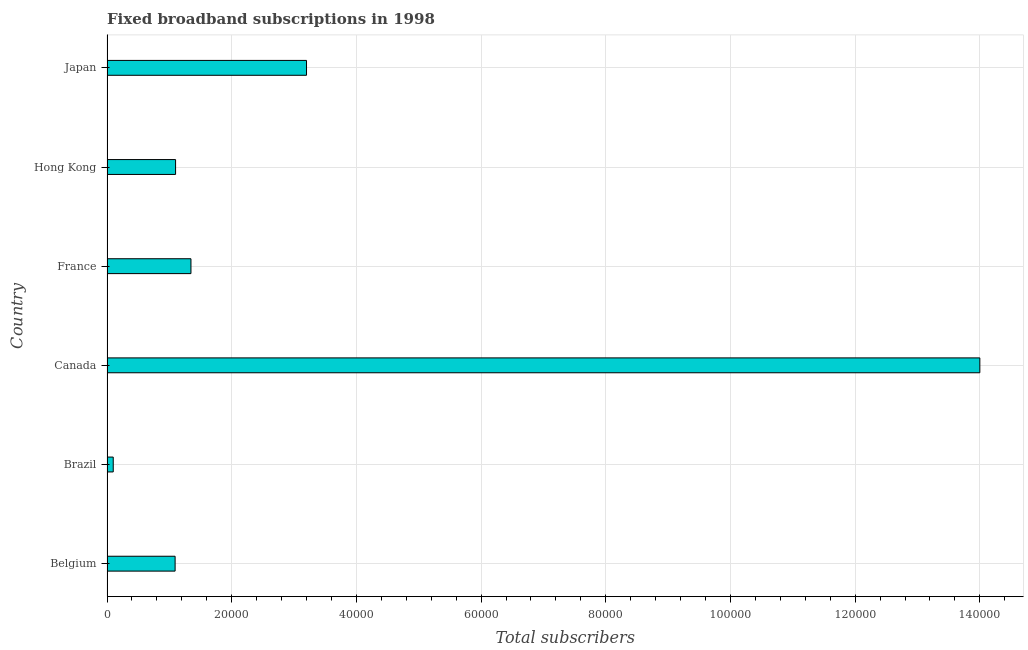Does the graph contain any zero values?
Ensure brevity in your answer.  No. What is the title of the graph?
Offer a very short reply. Fixed broadband subscriptions in 1998. What is the label or title of the X-axis?
Keep it short and to the point. Total subscribers. What is the total number of fixed broadband subscriptions in Hong Kong?
Your answer should be very brief. 1.10e+04. Across all countries, what is the minimum total number of fixed broadband subscriptions?
Give a very brief answer. 1000. In which country was the total number of fixed broadband subscriptions minimum?
Keep it short and to the point. Brazil. What is the sum of the total number of fixed broadband subscriptions?
Offer a terse response. 2.08e+05. What is the difference between the total number of fixed broadband subscriptions in Belgium and Canada?
Your answer should be compact. -1.29e+05. What is the average total number of fixed broadband subscriptions per country?
Offer a very short reply. 3.47e+04. What is the median total number of fixed broadband subscriptions?
Your answer should be very brief. 1.22e+04. In how many countries, is the total number of fixed broadband subscriptions greater than 40000 ?
Provide a succinct answer. 1. What is the ratio of the total number of fixed broadband subscriptions in Belgium to that in Hong Kong?
Ensure brevity in your answer.  0.99. Is the difference between the total number of fixed broadband subscriptions in Belgium and Canada greater than the difference between any two countries?
Provide a succinct answer. No. What is the difference between the highest and the second highest total number of fixed broadband subscriptions?
Give a very brief answer. 1.08e+05. What is the difference between the highest and the lowest total number of fixed broadband subscriptions?
Ensure brevity in your answer.  1.39e+05. In how many countries, is the total number of fixed broadband subscriptions greater than the average total number of fixed broadband subscriptions taken over all countries?
Your answer should be compact. 1. How many countries are there in the graph?
Keep it short and to the point. 6. Are the values on the major ticks of X-axis written in scientific E-notation?
Provide a succinct answer. No. What is the Total subscribers in Belgium?
Provide a short and direct response. 1.09e+04. What is the Total subscribers in France?
Ensure brevity in your answer.  1.35e+04. What is the Total subscribers in Hong Kong?
Ensure brevity in your answer.  1.10e+04. What is the Total subscribers of Japan?
Offer a very short reply. 3.20e+04. What is the difference between the Total subscribers in Belgium and Brazil?
Your answer should be very brief. 9924. What is the difference between the Total subscribers in Belgium and Canada?
Provide a short and direct response. -1.29e+05. What is the difference between the Total subscribers in Belgium and France?
Offer a very short reply. -2540. What is the difference between the Total subscribers in Belgium and Hong Kong?
Make the answer very short. -76. What is the difference between the Total subscribers in Belgium and Japan?
Give a very brief answer. -2.11e+04. What is the difference between the Total subscribers in Brazil and Canada?
Your response must be concise. -1.39e+05. What is the difference between the Total subscribers in Brazil and France?
Keep it short and to the point. -1.25e+04. What is the difference between the Total subscribers in Brazil and Japan?
Your answer should be compact. -3.10e+04. What is the difference between the Total subscribers in Canada and France?
Provide a short and direct response. 1.27e+05. What is the difference between the Total subscribers in Canada and Hong Kong?
Your answer should be compact. 1.29e+05. What is the difference between the Total subscribers in Canada and Japan?
Offer a very short reply. 1.08e+05. What is the difference between the Total subscribers in France and Hong Kong?
Keep it short and to the point. 2464. What is the difference between the Total subscribers in France and Japan?
Offer a terse response. -1.85e+04. What is the difference between the Total subscribers in Hong Kong and Japan?
Ensure brevity in your answer.  -2.10e+04. What is the ratio of the Total subscribers in Belgium to that in Brazil?
Ensure brevity in your answer.  10.92. What is the ratio of the Total subscribers in Belgium to that in Canada?
Your answer should be very brief. 0.08. What is the ratio of the Total subscribers in Belgium to that in France?
Offer a terse response. 0.81. What is the ratio of the Total subscribers in Belgium to that in Hong Kong?
Your response must be concise. 0.99. What is the ratio of the Total subscribers in Belgium to that in Japan?
Offer a terse response. 0.34. What is the ratio of the Total subscribers in Brazil to that in Canada?
Ensure brevity in your answer.  0.01. What is the ratio of the Total subscribers in Brazil to that in France?
Ensure brevity in your answer.  0.07. What is the ratio of the Total subscribers in Brazil to that in Hong Kong?
Give a very brief answer. 0.09. What is the ratio of the Total subscribers in Brazil to that in Japan?
Ensure brevity in your answer.  0.03. What is the ratio of the Total subscribers in Canada to that in France?
Your answer should be very brief. 10.4. What is the ratio of the Total subscribers in Canada to that in Hong Kong?
Your response must be concise. 12.73. What is the ratio of the Total subscribers in Canada to that in Japan?
Offer a very short reply. 4.38. What is the ratio of the Total subscribers in France to that in Hong Kong?
Your response must be concise. 1.22. What is the ratio of the Total subscribers in France to that in Japan?
Make the answer very short. 0.42. What is the ratio of the Total subscribers in Hong Kong to that in Japan?
Make the answer very short. 0.34. 